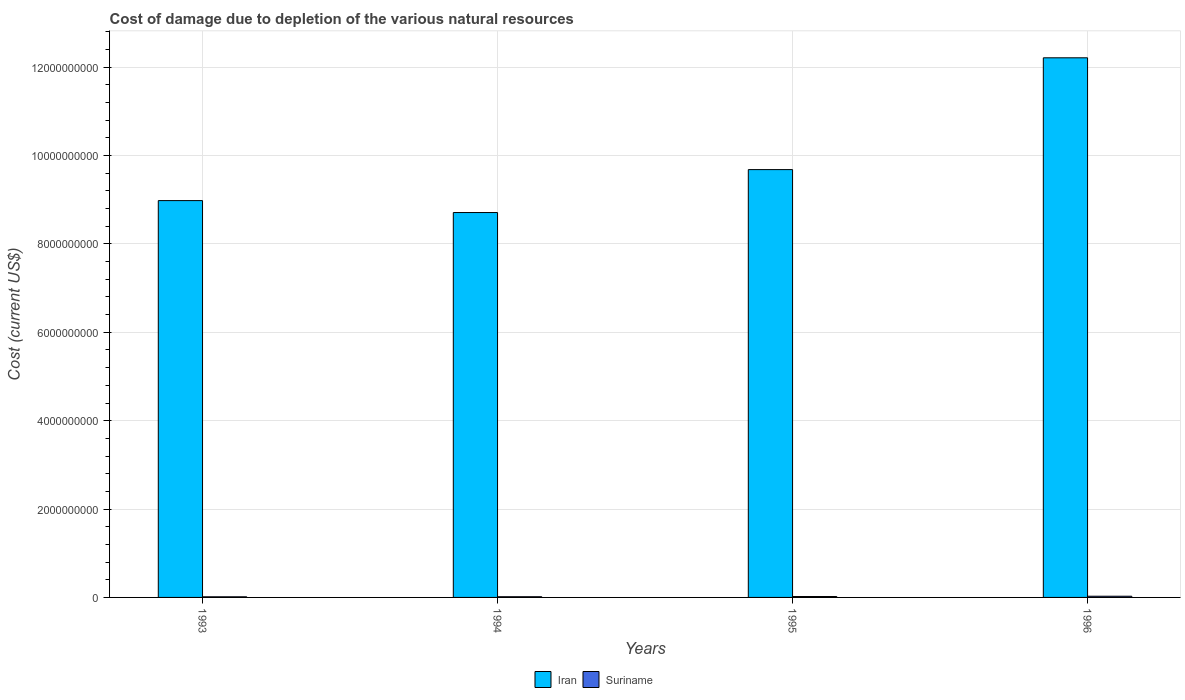How many groups of bars are there?
Give a very brief answer. 4. Are the number of bars on each tick of the X-axis equal?
Offer a very short reply. Yes. What is the label of the 4th group of bars from the left?
Your response must be concise. 1996. What is the cost of damage caused due to the depletion of various natural resources in Iran in 1995?
Provide a succinct answer. 9.68e+09. Across all years, what is the maximum cost of damage caused due to the depletion of various natural resources in Suriname?
Provide a succinct answer. 2.73e+07. Across all years, what is the minimum cost of damage caused due to the depletion of various natural resources in Iran?
Offer a terse response. 8.71e+09. In which year was the cost of damage caused due to the depletion of various natural resources in Iran minimum?
Make the answer very short. 1994. What is the total cost of damage caused due to the depletion of various natural resources in Iran in the graph?
Your response must be concise. 3.96e+1. What is the difference between the cost of damage caused due to the depletion of various natural resources in Iran in 1993 and that in 1995?
Keep it short and to the point. -7.02e+08. What is the difference between the cost of damage caused due to the depletion of various natural resources in Suriname in 1993 and the cost of damage caused due to the depletion of various natural resources in Iran in 1994?
Offer a terse response. -8.70e+09. What is the average cost of damage caused due to the depletion of various natural resources in Suriname per year?
Your answer should be compact. 1.94e+07. In the year 1995, what is the difference between the cost of damage caused due to the depletion of various natural resources in Iran and cost of damage caused due to the depletion of various natural resources in Suriname?
Offer a very short reply. 9.66e+09. In how many years, is the cost of damage caused due to the depletion of various natural resources in Iran greater than 11200000000 US$?
Ensure brevity in your answer.  1. What is the ratio of the cost of damage caused due to the depletion of various natural resources in Suriname in 1993 to that in 1996?
Your answer should be compact. 0.52. Is the cost of damage caused due to the depletion of various natural resources in Iran in 1994 less than that in 1996?
Your answer should be very brief. Yes. Is the difference between the cost of damage caused due to the depletion of various natural resources in Iran in 1993 and 1996 greater than the difference between the cost of damage caused due to the depletion of various natural resources in Suriname in 1993 and 1996?
Offer a terse response. No. What is the difference between the highest and the second highest cost of damage caused due to the depletion of various natural resources in Suriname?
Offer a very short reply. 6.81e+06. What is the difference between the highest and the lowest cost of damage caused due to the depletion of various natural resources in Iran?
Your answer should be very brief. 3.50e+09. Is the sum of the cost of damage caused due to the depletion of various natural resources in Suriname in 1994 and 1995 greater than the maximum cost of damage caused due to the depletion of various natural resources in Iran across all years?
Your response must be concise. No. What does the 2nd bar from the left in 1994 represents?
Keep it short and to the point. Suriname. What does the 2nd bar from the right in 1993 represents?
Your response must be concise. Iran. Are the values on the major ticks of Y-axis written in scientific E-notation?
Provide a succinct answer. No. Does the graph contain any zero values?
Make the answer very short. No. Does the graph contain grids?
Provide a succinct answer. Yes. What is the title of the graph?
Keep it short and to the point. Cost of damage due to depletion of the various natural resources. What is the label or title of the X-axis?
Make the answer very short. Years. What is the label or title of the Y-axis?
Make the answer very short. Cost (current US$). What is the Cost (current US$) of Iran in 1993?
Ensure brevity in your answer.  8.98e+09. What is the Cost (current US$) in Suriname in 1993?
Keep it short and to the point. 1.42e+07. What is the Cost (current US$) of Iran in 1994?
Provide a succinct answer. 8.71e+09. What is the Cost (current US$) in Suriname in 1994?
Keep it short and to the point. 1.57e+07. What is the Cost (current US$) in Iran in 1995?
Give a very brief answer. 9.68e+09. What is the Cost (current US$) in Suriname in 1995?
Offer a very short reply. 2.05e+07. What is the Cost (current US$) in Iran in 1996?
Provide a succinct answer. 1.22e+1. What is the Cost (current US$) of Suriname in 1996?
Your answer should be compact. 2.73e+07. Across all years, what is the maximum Cost (current US$) in Iran?
Your answer should be very brief. 1.22e+1. Across all years, what is the maximum Cost (current US$) of Suriname?
Provide a succinct answer. 2.73e+07. Across all years, what is the minimum Cost (current US$) of Iran?
Ensure brevity in your answer.  8.71e+09. Across all years, what is the minimum Cost (current US$) in Suriname?
Give a very brief answer. 1.42e+07. What is the total Cost (current US$) of Iran in the graph?
Give a very brief answer. 3.96e+1. What is the total Cost (current US$) in Suriname in the graph?
Keep it short and to the point. 7.77e+07. What is the difference between the Cost (current US$) of Iran in 1993 and that in 1994?
Make the answer very short. 2.70e+08. What is the difference between the Cost (current US$) in Suriname in 1993 and that in 1994?
Your response must be concise. -1.47e+06. What is the difference between the Cost (current US$) in Iran in 1993 and that in 1995?
Make the answer very short. -7.02e+08. What is the difference between the Cost (current US$) in Suriname in 1993 and that in 1995?
Offer a terse response. -6.29e+06. What is the difference between the Cost (current US$) in Iran in 1993 and that in 1996?
Your answer should be compact. -3.23e+09. What is the difference between the Cost (current US$) in Suriname in 1993 and that in 1996?
Offer a very short reply. -1.31e+07. What is the difference between the Cost (current US$) of Iran in 1994 and that in 1995?
Give a very brief answer. -9.72e+08. What is the difference between the Cost (current US$) of Suriname in 1994 and that in 1995?
Provide a succinct answer. -4.82e+06. What is the difference between the Cost (current US$) in Iran in 1994 and that in 1996?
Provide a short and direct response. -3.50e+09. What is the difference between the Cost (current US$) in Suriname in 1994 and that in 1996?
Keep it short and to the point. -1.16e+07. What is the difference between the Cost (current US$) of Iran in 1995 and that in 1996?
Your answer should be compact. -2.53e+09. What is the difference between the Cost (current US$) in Suriname in 1995 and that in 1996?
Your response must be concise. -6.81e+06. What is the difference between the Cost (current US$) in Iran in 1993 and the Cost (current US$) in Suriname in 1994?
Make the answer very short. 8.97e+09. What is the difference between the Cost (current US$) of Iran in 1993 and the Cost (current US$) of Suriname in 1995?
Give a very brief answer. 8.96e+09. What is the difference between the Cost (current US$) of Iran in 1993 and the Cost (current US$) of Suriname in 1996?
Give a very brief answer. 8.95e+09. What is the difference between the Cost (current US$) in Iran in 1994 and the Cost (current US$) in Suriname in 1995?
Ensure brevity in your answer.  8.69e+09. What is the difference between the Cost (current US$) of Iran in 1994 and the Cost (current US$) of Suriname in 1996?
Provide a succinct answer. 8.68e+09. What is the difference between the Cost (current US$) in Iran in 1995 and the Cost (current US$) in Suriname in 1996?
Your answer should be compact. 9.66e+09. What is the average Cost (current US$) of Iran per year?
Ensure brevity in your answer.  9.90e+09. What is the average Cost (current US$) in Suriname per year?
Keep it short and to the point. 1.94e+07. In the year 1993, what is the difference between the Cost (current US$) in Iran and Cost (current US$) in Suriname?
Provide a succinct answer. 8.97e+09. In the year 1994, what is the difference between the Cost (current US$) of Iran and Cost (current US$) of Suriname?
Offer a very short reply. 8.70e+09. In the year 1995, what is the difference between the Cost (current US$) in Iran and Cost (current US$) in Suriname?
Your answer should be very brief. 9.66e+09. In the year 1996, what is the difference between the Cost (current US$) of Iran and Cost (current US$) of Suriname?
Your response must be concise. 1.22e+1. What is the ratio of the Cost (current US$) in Iran in 1993 to that in 1994?
Give a very brief answer. 1.03. What is the ratio of the Cost (current US$) of Suriname in 1993 to that in 1994?
Give a very brief answer. 0.91. What is the ratio of the Cost (current US$) in Iran in 1993 to that in 1995?
Your answer should be very brief. 0.93. What is the ratio of the Cost (current US$) in Suriname in 1993 to that in 1995?
Your answer should be compact. 0.69. What is the ratio of the Cost (current US$) in Iran in 1993 to that in 1996?
Your answer should be very brief. 0.74. What is the ratio of the Cost (current US$) in Suriname in 1993 to that in 1996?
Provide a succinct answer. 0.52. What is the ratio of the Cost (current US$) of Iran in 1994 to that in 1995?
Provide a short and direct response. 0.9. What is the ratio of the Cost (current US$) of Suriname in 1994 to that in 1995?
Provide a short and direct response. 0.76. What is the ratio of the Cost (current US$) of Iran in 1994 to that in 1996?
Your answer should be compact. 0.71. What is the ratio of the Cost (current US$) in Suriname in 1994 to that in 1996?
Your response must be concise. 0.57. What is the ratio of the Cost (current US$) in Iran in 1995 to that in 1996?
Your answer should be very brief. 0.79. What is the ratio of the Cost (current US$) in Suriname in 1995 to that in 1996?
Make the answer very short. 0.75. What is the difference between the highest and the second highest Cost (current US$) in Iran?
Provide a short and direct response. 2.53e+09. What is the difference between the highest and the second highest Cost (current US$) in Suriname?
Give a very brief answer. 6.81e+06. What is the difference between the highest and the lowest Cost (current US$) in Iran?
Make the answer very short. 3.50e+09. What is the difference between the highest and the lowest Cost (current US$) in Suriname?
Your response must be concise. 1.31e+07. 